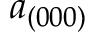Convert formula to latex. <formula><loc_0><loc_0><loc_500><loc_500>a _ { ( 0 0 0 ) }</formula> 